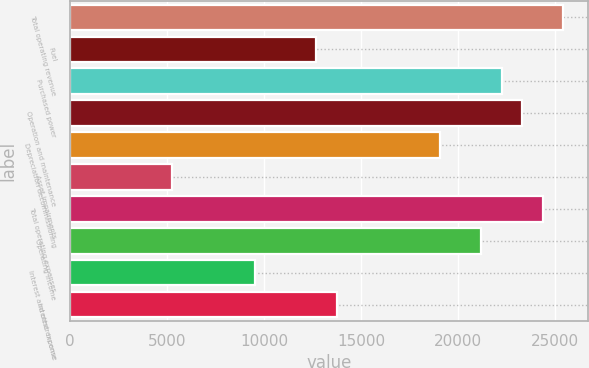Convert chart. <chart><loc_0><loc_0><loc_500><loc_500><bar_chart><fcel>Total operating revenue<fcel>Fuel<fcel>Purchased power<fcel>Operation and maintenance<fcel>Depreciation decommissioning<fcel>Asset impairments<fcel>Total operating expenses<fcel>Operating income<fcel>Interest and other income<fcel>Interest expense<nl><fcel>25411.1<fcel>12705.6<fcel>22234.7<fcel>23293.5<fcel>19058.3<fcel>5294.06<fcel>24352.3<fcel>21175.9<fcel>9529.22<fcel>13764.4<nl></chart> 